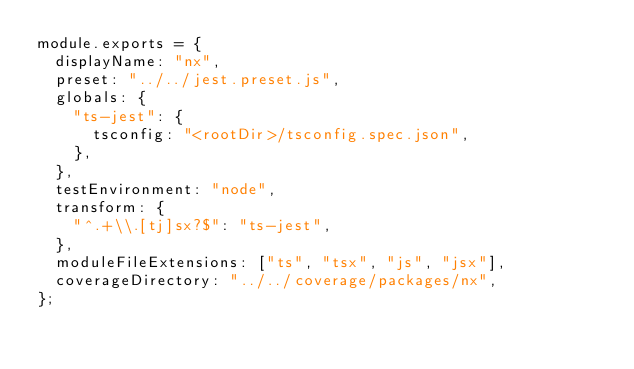<code> <loc_0><loc_0><loc_500><loc_500><_JavaScript_>module.exports = {
	displayName: "nx",
	preset: "../../jest.preset.js",
	globals: {
		"ts-jest": {
			tsconfig: "<rootDir>/tsconfig.spec.json",
		},
	},
	testEnvironment: "node",
	transform: {
		"^.+\\.[tj]sx?$": "ts-jest",
	},
	moduleFileExtensions: ["ts", "tsx", "js", "jsx"],
	coverageDirectory: "../../coverage/packages/nx",
};
</code> 